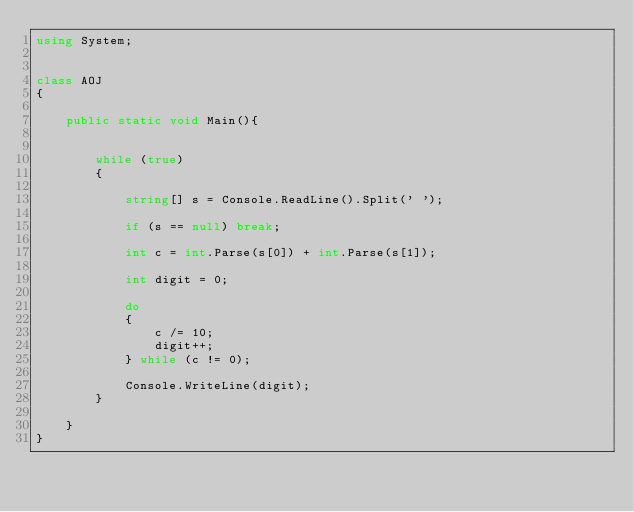Convert code to text. <code><loc_0><loc_0><loc_500><loc_500><_C#_>using System;


class AOJ
{

    public static void Main(){


        while (true)
        {

            string[] s = Console.ReadLine().Split(' ');

            if (s == null) break;

            int c = int.Parse(s[0]) + int.Parse(s[1]);

            int digit = 0;

            do
            {
                c /= 10;
                digit++;
            } while (c != 0);

            Console.WriteLine(digit);
        }

    }
}</code> 